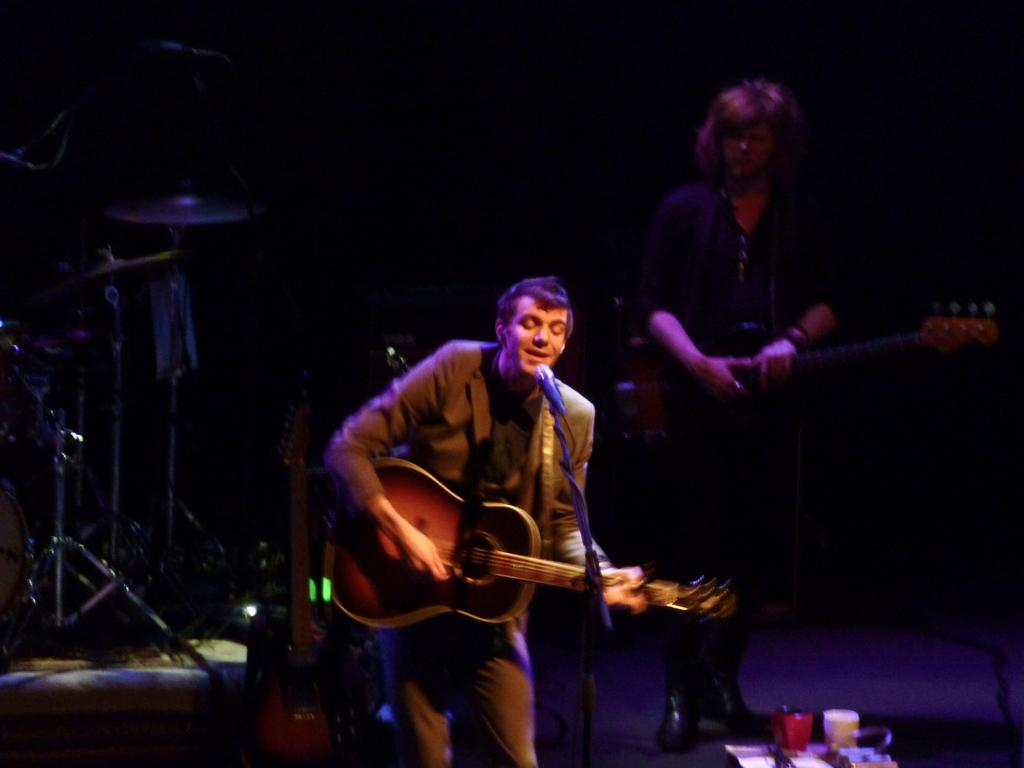What is the man in the image doing? The man is singing on a mic and playing a guitar. What other musical instruments can be seen in the image? There are musical instruments in the background. Can you describe the person in the background? The person in the background is holding a guitar. What is on the table on the right side of the image? There are cups on a table on the right side of the image. How many legs does the chalk have in the image? There is no chalk present in the image. What type of dish is the cook preparing in the image? There is no cook or dish preparation present in the image. 